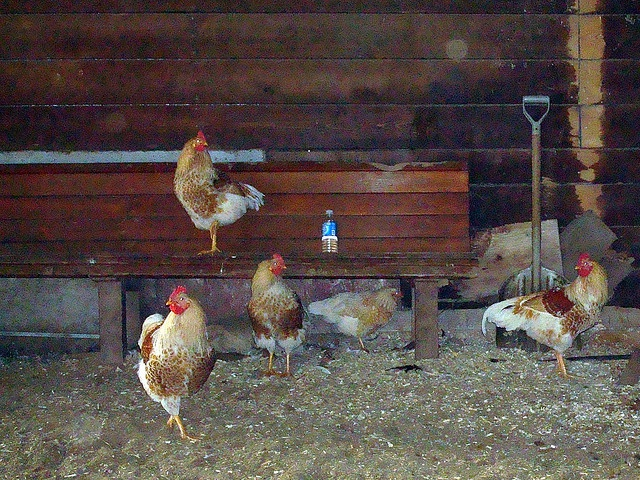Describe the objects in this image and their specific colors. I can see bench in black, maroon, and gray tones, bird in black, ivory, darkgray, gray, and tan tones, bird in black, darkgray, tan, maroon, and lightgray tones, bird in black, darkgray, tan, and gray tones, and bird in black, gray, darkgray, tan, and maroon tones in this image. 